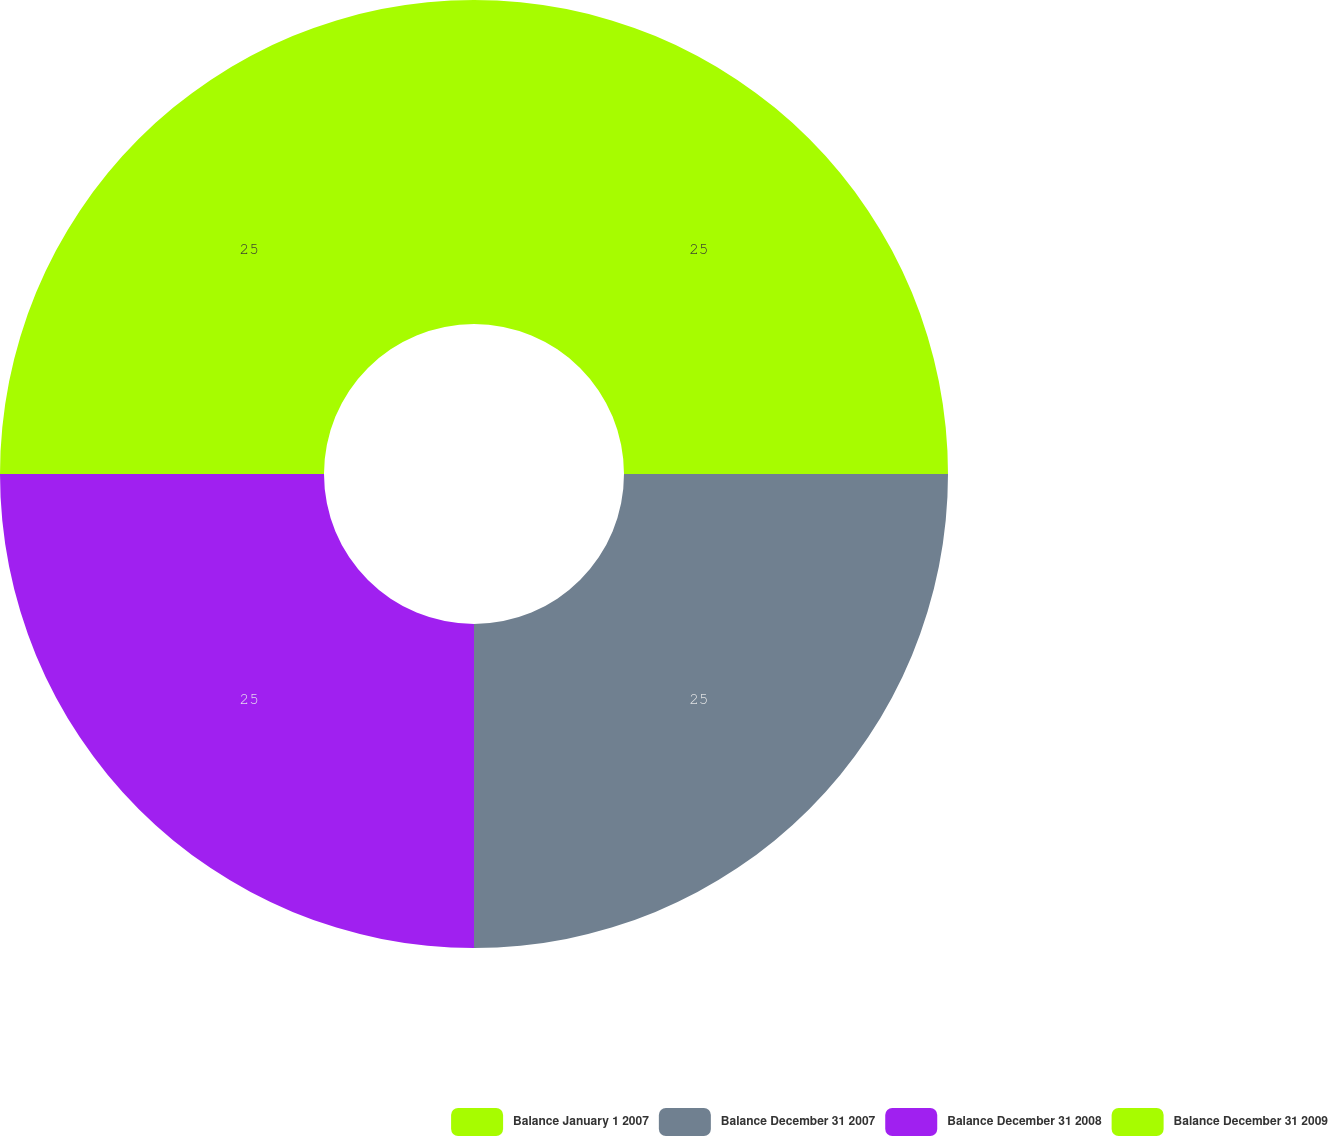Convert chart. <chart><loc_0><loc_0><loc_500><loc_500><pie_chart><fcel>Balance January 1 2007<fcel>Balance December 31 2007<fcel>Balance December 31 2008<fcel>Balance December 31 2009<nl><fcel>25.0%<fcel>25.0%<fcel>25.0%<fcel>25.0%<nl></chart> 